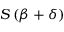<formula> <loc_0><loc_0><loc_500><loc_500>S \left ( { \beta } + { \delta } \right )</formula> 